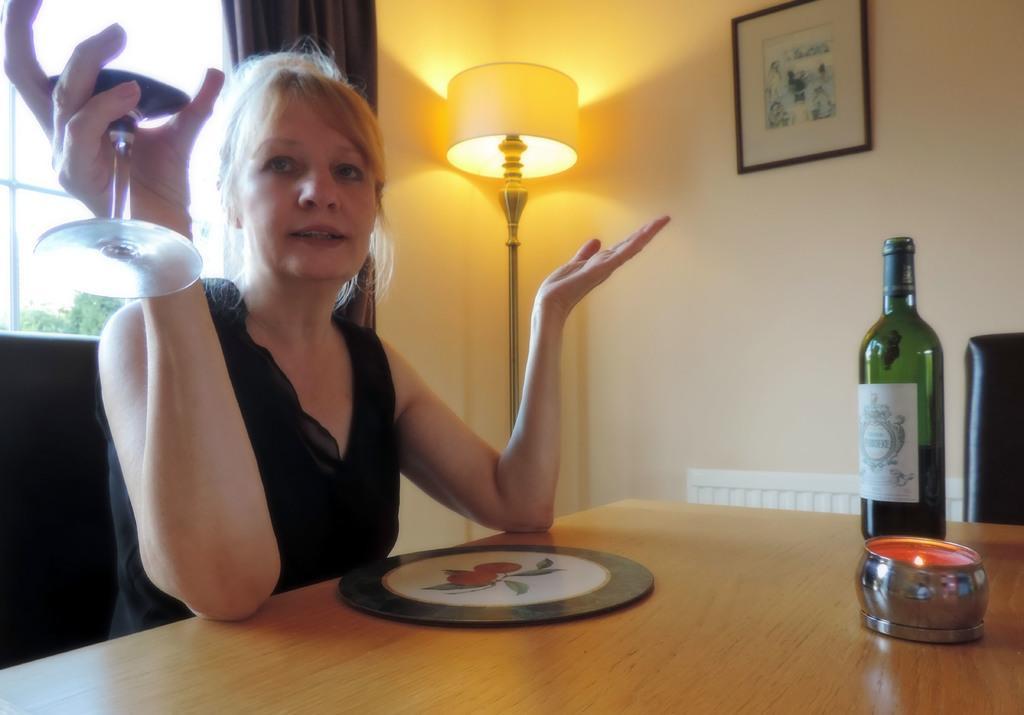Describe this image in one or two sentences. This picture is taken in a room. There is a woman sitting on chair at the table and holding wine glass in her hand. On the table there is a bottle and a candle. Beside her there is lamp. Behind her there is window and through it sky and trees can be seen. In the background there is wall, curtain, switch board to the wall and picture frame hanging on the wall. 